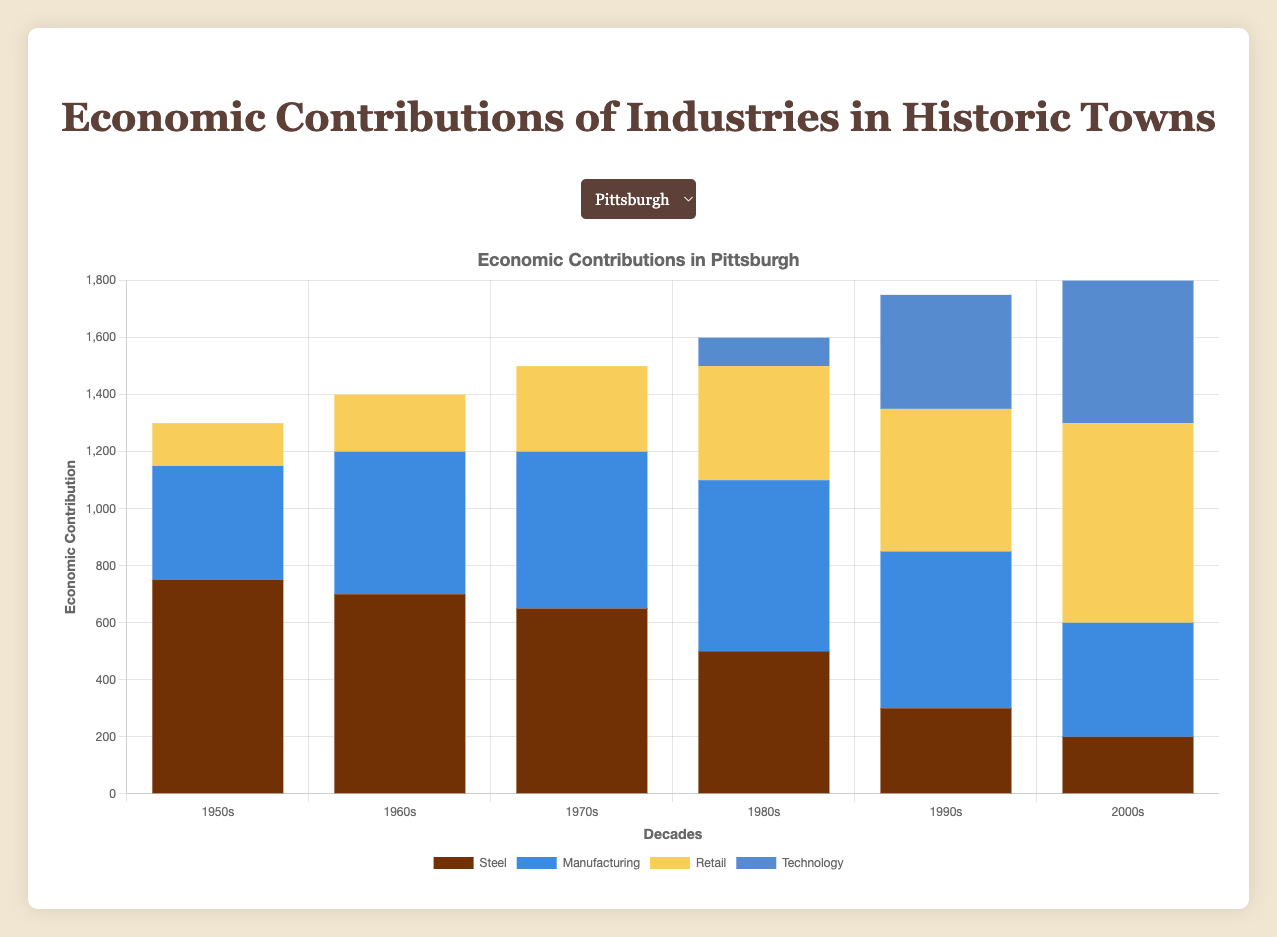Which town had the highest economic contribution from the Healthcare industry in the 2000s? We need to look at the height of the bars representing Healthcare for all towns in the 2000s. Scranton has the tallest bar for Healthcare during this period.
Answer: Scranton In the 1980s, which industry had the lowest economic contribution in Pittsburgh? By examining the heights of the bars for each industry in Pittsburgh during the 1980s, the Technology bar is the shortest.
Answer: Technology What is the combined economic contribution of the Steel and Retail industries in Pittsburgh in the 1990s? Add the contributions of the Steel and Retail industries for Pittsburgh in the 1990s from the figure. Steel contributes 300 and Retail contributes 500. So, 300 + 500 = 800.
Answer: 800 Which industry showed the most growth between the 1950s and the 2000s in Lowell? By comparing the bar heights for each industry in Lowell between the 1950s and the 2000s, the Retail industry shows the largest increase in height from its 1950s level.
Answer: Retail How did the Manufacturing industry's economic contribution in Scranton in the 1980s compare to the 1970s? Compare the bar heights for Manufacturing in Scranton between the 1970s and 1980s. The 1980s bar is slightly taller.
Answer: Increased Which industry had the most significant decline between the 1950s and 2000s in Pittsburgh? By comparing the bar heights for each industry in Pittsburgh between these decades, the Steel industry shows the most considerable decrease.
Answer: Steel What is the average economic contribution of the Textiles industry in Lowell from 1950s to 2000s? Sum the Textiles contributions across all decades in Lowell and divide by the number of decades (600 + 500 + 400 + 300 + 200 + 100 = 2100; 2100 / 6).
Answer: 350 In the 1970s, which town had the highest total economic contribution from all industries combined? Sum the heights of the bars for each town in the 1970s. Pittsburgh has the highest combined bar heights compared to Lowell and Scranton.
Answer: Pittsburgh What is the difference in economic contribution between Coal Mining in the 1950s and 2000s in Scranton? Subtract the economic contribution of Coal Mining in the 2000s from that in the 1950s (800 - 300).
Answer: 500 